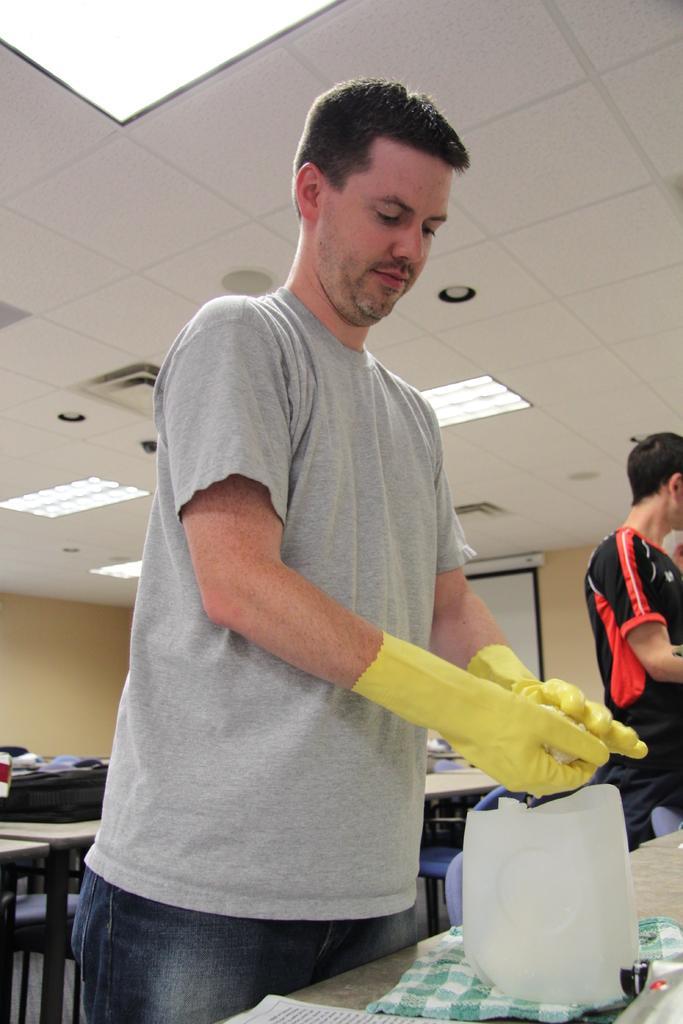How would you summarize this image in a sentence or two? This image consists of a man wearing gloves. In the background, there are tables. At the top, there is a roof along with the lights. To the right, there is a machine kept on the desk. 